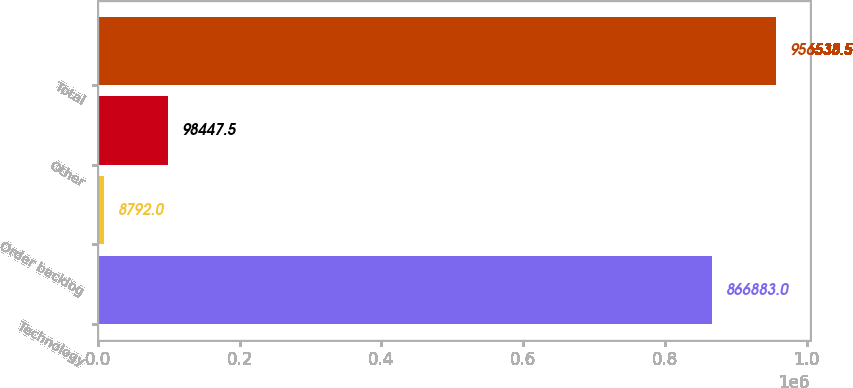<chart> <loc_0><loc_0><loc_500><loc_500><bar_chart><fcel>Technology<fcel>Order backlog<fcel>Other<fcel>Total<nl><fcel>866883<fcel>8792<fcel>98447.5<fcel>956538<nl></chart> 